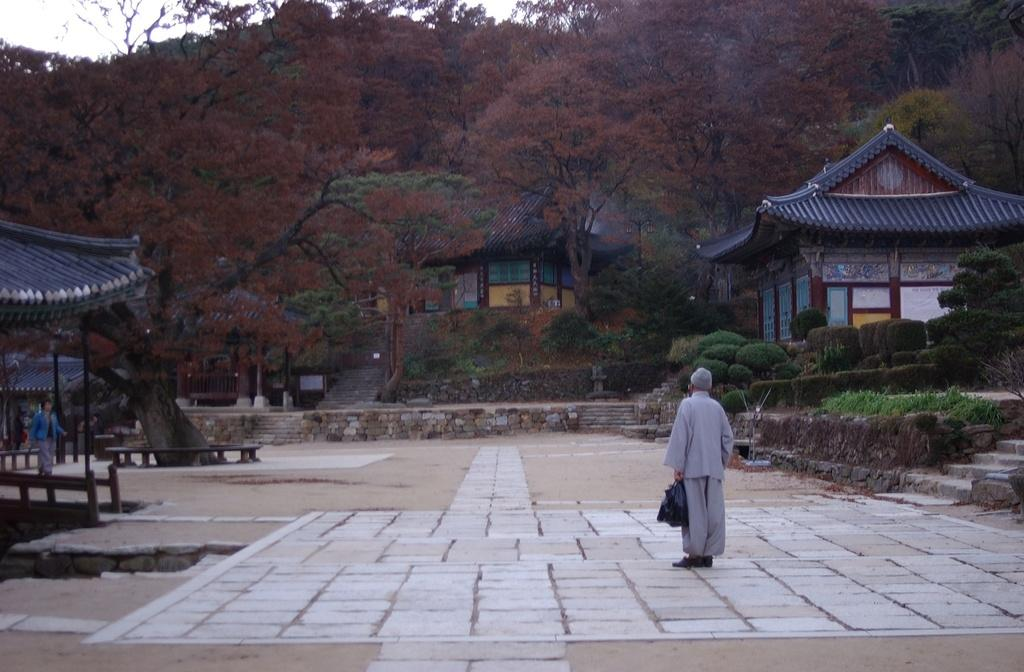How many people are in the image? There is a group of people in the image. What can be seen in the background of the image? There are plants, trees, and houses in the background of the image. Can you describe the man in the middle of the image? The man in the middle of the image is holding a bag. How does the man sleep while holding the bag in the image? The man is not sleeping in the image; he is standing and holding a bag. What type of milk can be seen in the image? There is no milk present in the image. 